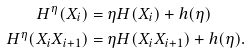Convert formula to latex. <formula><loc_0><loc_0><loc_500><loc_500>H ^ { \eta } ( X _ { i } ) & = \eta H ( X _ { i } ) + h ( \eta ) \\ H ^ { \eta } ( X _ { i } X _ { i + 1 } ) & = \eta H ( X _ { i } X _ { i + 1 } ) + h ( \eta ) .</formula> 